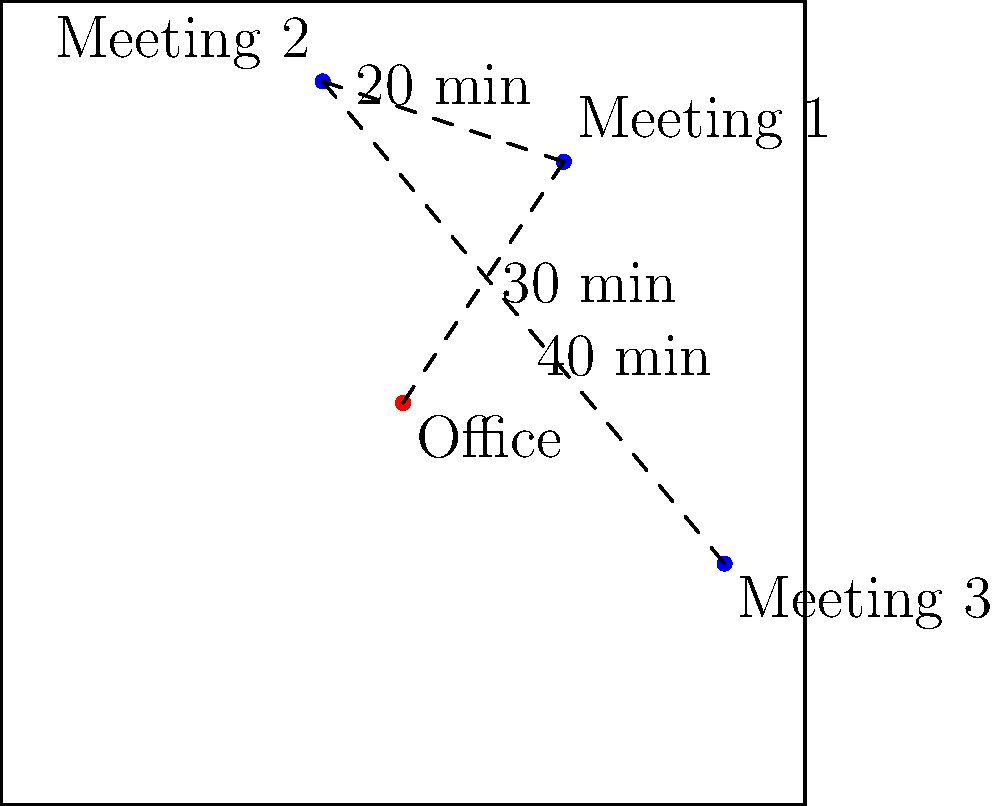Based on the map showing your office location and three meetings, what is the minimum total travel time required to attend all meetings sequentially, starting and ending at the office, assuming you can choose the order of the meetings? To solve this problem, we need to consider all possible routes and calculate their total travel times:

1. Office → Meeting 1 → Meeting 2 → Meeting 3 → Office
   Time: 30 + 20 + 40 + (Office to Meeting 3 time) minutes

2. Office → Meeting 1 → Meeting 3 → Meeting 2 → Office
   Time: 30 + (Meeting 1 to Meeting 3 time) + 40 + (Office to Meeting 2 time) minutes

3. Office → Meeting 2 → Meeting 1 → Meeting 3 → Office
   Time: (Office to Meeting 2 time) + 20 + 30 + (Office to Meeting 3 time) minutes

4. Office → Meeting 2 → Meeting 3 → Meeting 1 → Office
   Time: (Office to Meeting 2 time) + 40 + (Meeting 3 to Meeting 1 time) + 30 minutes

5. Office → Meeting 3 → Meeting 1 → Meeting 2 → Office
   Time: (Office to Meeting 3 time) + (Meeting 3 to Meeting 1 time) + 20 + (Office to Meeting 2 time) minutes

6. Office → Meeting 3 → Meeting 2 → Meeting 1 → Office
   Time: (Office to Meeting 3 time) + 40 + 20 + 30 minutes

The unknown travel times can be estimated based on the relative distances on the map. However, we can see that routes 1 and 6 have all their travel times given.

Route 1: 30 + 20 + 40 + (Office to Meeting 3 time) = 90 + (Office to Meeting 3 time)
Route 6: (Office to Meeting 3 time) + 40 + 20 + 30 = 90 + (Office to Meeting 3 time)

Both routes have the same total time, which is less than or equal to the other routes (as they include additional unknown times). Therefore, the minimum total travel time is achieved by either route 1 or route 6, resulting in 90 minutes plus the time from Office to Meeting 3.

Estimating the time from Office to Meeting 3 based on the map (it appears to be slightly longer than the 30-minute path from Office to Meeting 1), we can approximate it to be about 35-40 minutes.

Thus, the minimum total travel time is approximately 90 + 40 = 130 minutes.
Answer: Approximately 130 minutes 